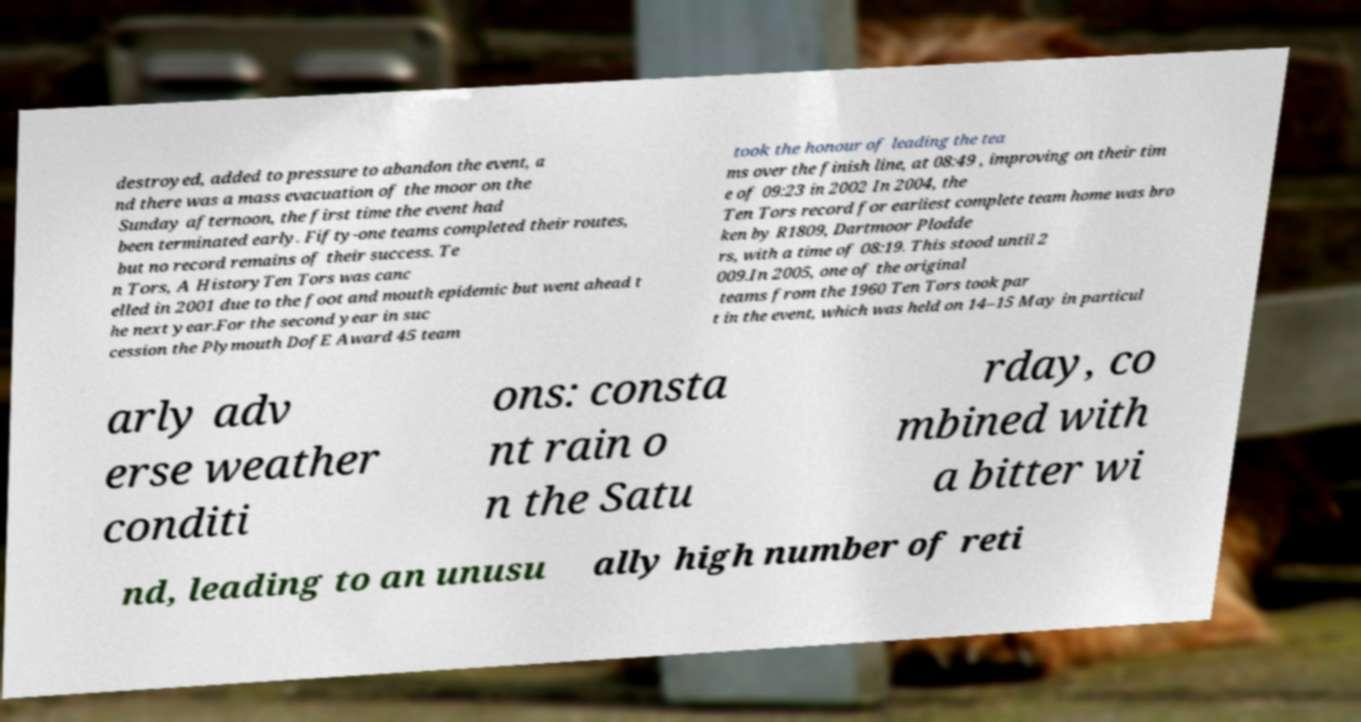Could you extract and type out the text from this image? destroyed, added to pressure to abandon the event, a nd there was a mass evacuation of the moor on the Sunday afternoon, the first time the event had been terminated early. Fifty-one teams completed their routes, but no record remains of their success. Te n Tors, A HistoryTen Tors was canc elled in 2001 due to the foot and mouth epidemic but went ahead t he next year.For the second year in suc cession the Plymouth DofE Award 45 team took the honour of leading the tea ms over the finish line, at 08:49 , improving on their tim e of 09:23 in 2002 In 2004, the Ten Tors record for earliest complete team home was bro ken by R1809, Dartmoor Plodde rs, with a time of 08:19. This stood until 2 009.In 2005, one of the original teams from the 1960 Ten Tors took par t in the event, which was held on 14–15 May in particul arly adv erse weather conditi ons: consta nt rain o n the Satu rday, co mbined with a bitter wi nd, leading to an unusu ally high number of reti 